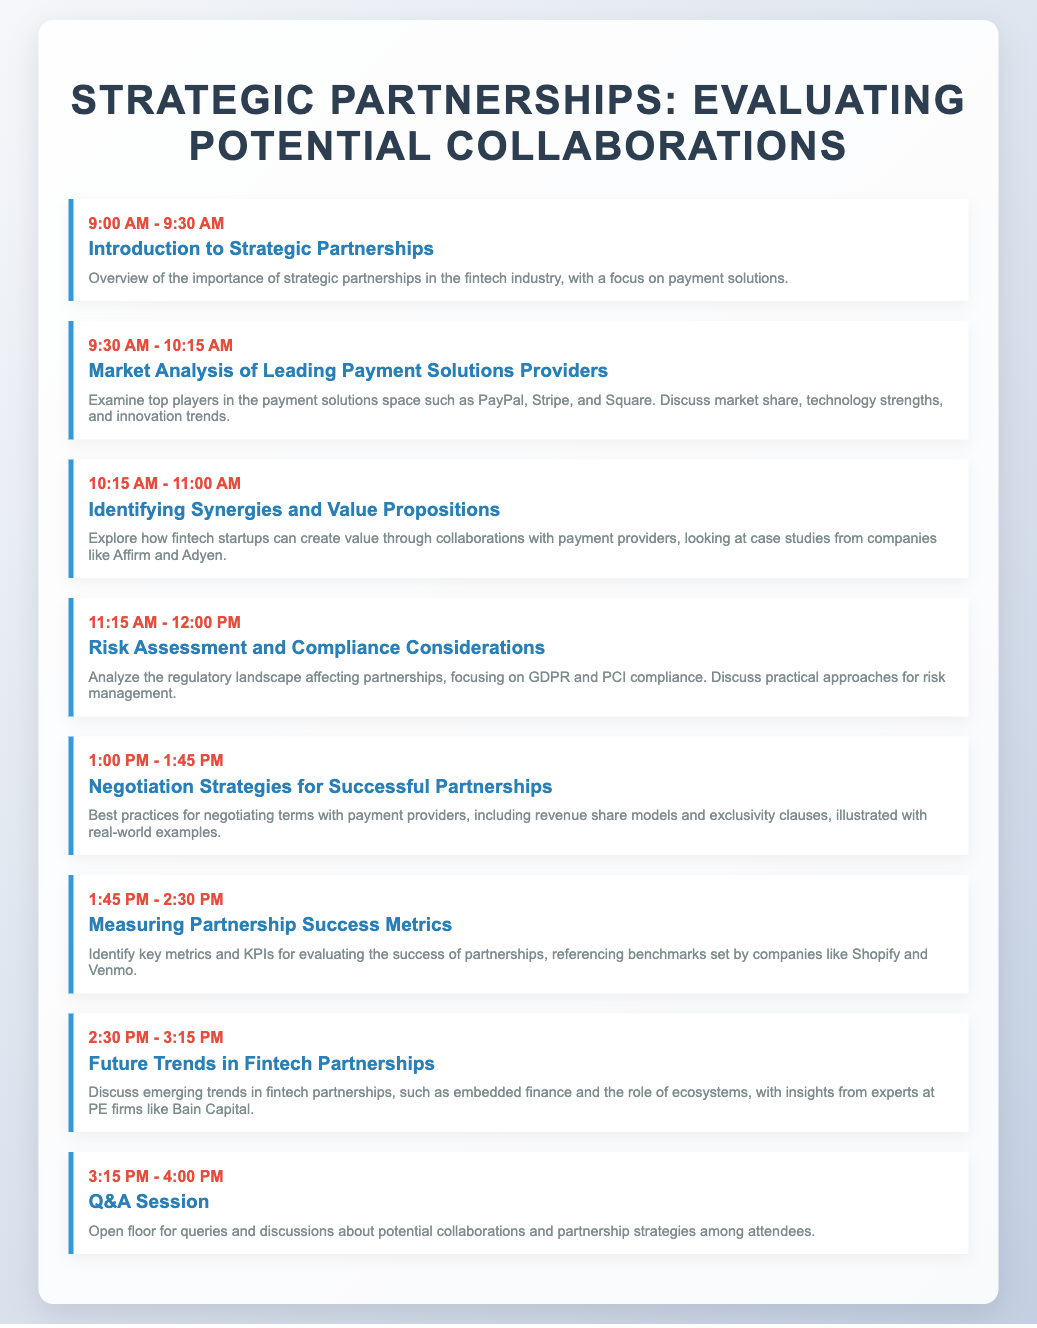What is the title of the agenda? The title is the main heading of the document, indicating the focus of the meeting.
Answer: Strategic Partnerships: Evaluating Potential Collaborations What time does the Introduction to Strategic Partnerships start? The starting time can be found in the agenda's time schedule.
Answer: 9:00 AM Who are three examples of leading payment solutions providers mentioned? These names are specifically listed in the agenda overview of leading players in the market.
Answer: PayPal, Stripe, Square What is the focus of the session held from 10:15 AM to 11:00 AM? This is indicated in the title of the agenda item during that time slot.
Answer: Identifying Synergies and Value Propositions What compliance considerations are analyzed in the agenda? The specific regulations discussed are listed in the relevant session.
Answer: GDPR and PCI compliance Which company is referenced in the measurement of partnership success metrics? The company is mentioned in the context of discussing benchmarks for success.
Answer: Shopify What is the last agenda item before the Q&A session? This can be found by looking at the session order in the document.
Answer: Future Trends in Fintech Partnerships What is the duration of the session on Negotiation Strategies for Successful Partnerships? The duration can be calculated by referencing the starting and ending times of the session.
Answer: 45 minutes 